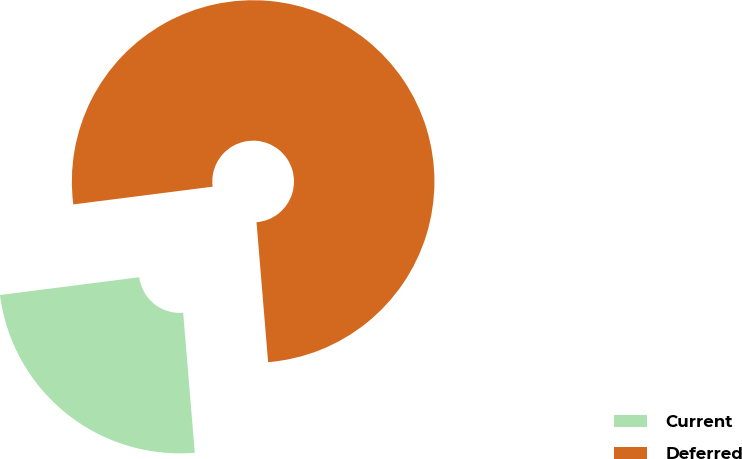Convert chart. <chart><loc_0><loc_0><loc_500><loc_500><pie_chart><fcel>Current<fcel>Deferred<nl><fcel>24.3%<fcel>75.7%<nl></chart> 